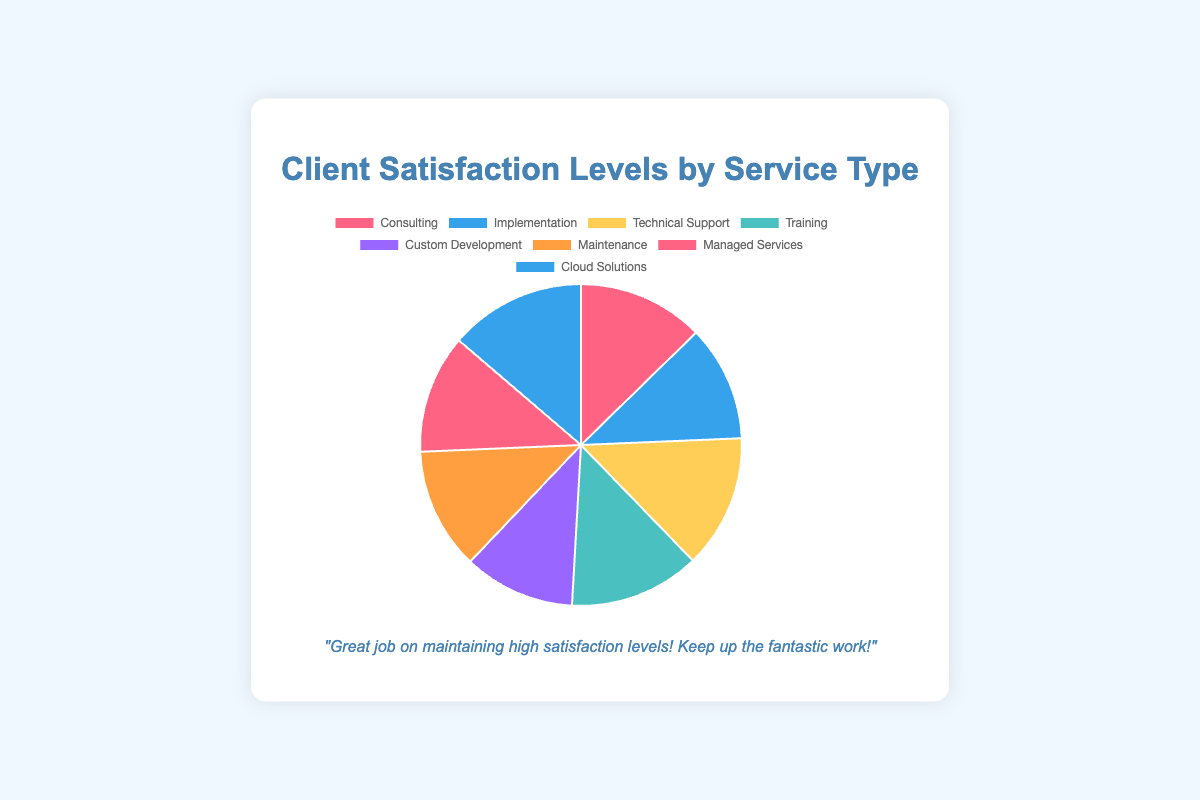What's the overall highest satisfaction level? The highest satisfaction level can be identified by examining the value for each service type. The highest value is 92 for Cloud Solutions.
Answer: Cloud Solutions Which service type has the lowest satisfaction level? The lowest satisfaction level can be identified by scanning through the values. The lowest value is 75 for Custom Development.
Answer: Custom Development How much higher is the satisfaction level for Technical Support compared to Implementation? The satisfaction level for Technical Support is 90, and for Implementation, it is 78. The difference is calculated as 90 - 78 = 12.
Answer: 12 What's the difference between the satisfaction levels of the highest and lowest service types? The highest satisfaction level is 92 (Cloud Solutions), and the lowest is 75 (Custom Development). The difference is 92 - 75 = 17.
Answer: 17 What's the average client satisfaction level across all service types? Summing all satisfaction levels: 85 + 78 + 90 + 88 + 75 + 82 + 80 + 92 = 670. There are 8 service types, so the average is 670 / 8 = 83.75.
Answer: 83.75 Which service type had a satisfaction level closest to the overall average? The overall average is 83.75. The closest satisfaction level is 85 for Consulting (85 is closer to 83.75 than the other values).
Answer: Consulting How many service types have a satisfaction level greater than 80? The satisfaction levels greater than 80 are 85, 90, 88, 82, and 92. This gives us 5 service types.
Answer: 5 Which two service types have the satisfaction levels closest to each other? The closest levels are for Managed Services (80) and Implementation (78). The difference is 2.
Answer: Managed Services and Implementation 